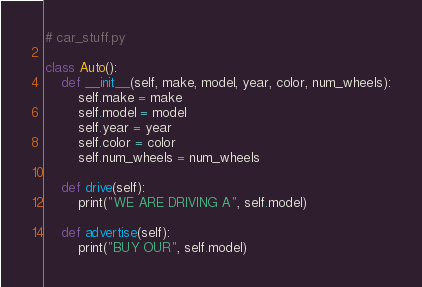<code> <loc_0><loc_0><loc_500><loc_500><_Python_># car_stuff.py

class Auto():
    def __init__(self, make, model, year, color, num_wheels):
        self.make = make
        self.model = model
        self.year = year
        self.color = color
        self.num_wheels = num_wheels

    def drive(self):
        print("WE ARE DRIVING A", self.model)

    def advertise(self):
        print("BUY OUR", self.model)
</code> 